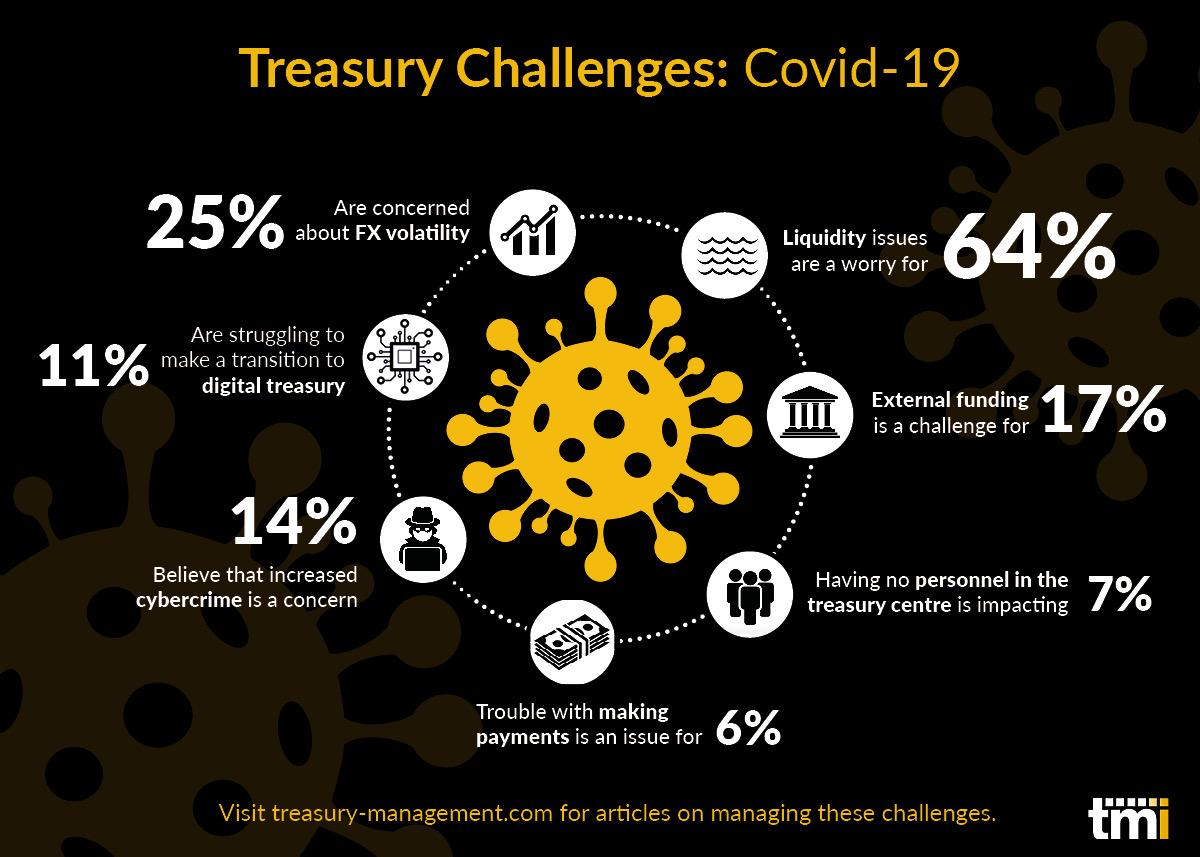Indicate a few pertinent items in this graphic. Covid-19 has caused significant challenges for treasury departments, and one of the major issues they have faced is a lack of liquidity due to the pandemic. Covid-19 has resulted in the least significant challenge for the treasury being making payments. 